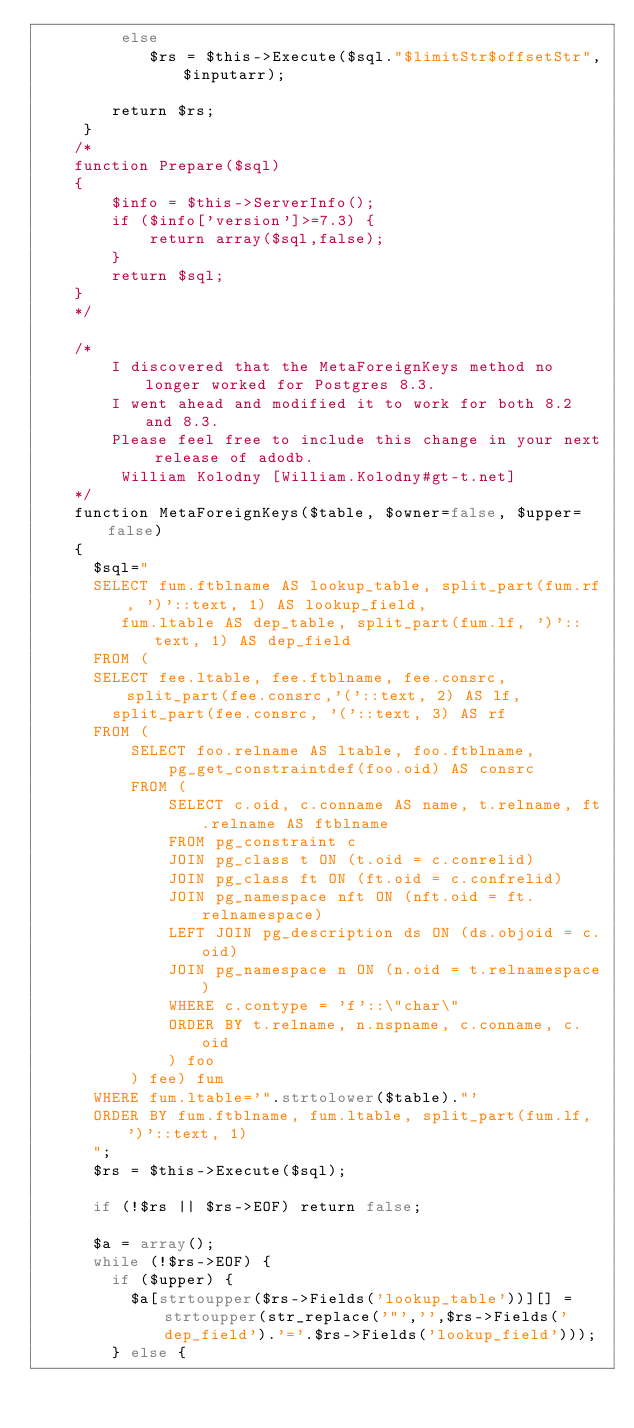<code> <loc_0><loc_0><loc_500><loc_500><_PHP_>		 else
		  	$rs = $this->Execute($sql."$limitStr$offsetStr",$inputarr);

		return $rs;
	 }
 	/*
 	function Prepare($sql)
	{
		$info = $this->ServerInfo();
		if ($info['version']>=7.3) {
			return array($sql,false);
		}
		return $sql;
	}
 	*/

	/*
		I discovered that the MetaForeignKeys method no longer worked for Postgres 8.3.
		I went ahead and modified it to work for both 8.2 and 8.3.
		Please feel free to include this change in your next release of adodb.
		 William Kolodny [William.Kolodny#gt-t.net]
	*/
	function MetaForeignKeys($table, $owner=false, $upper=false)
	{
	  $sql="
	  SELECT fum.ftblname AS lookup_table, split_part(fum.rf, ')'::text, 1) AS lookup_field,
	     fum.ltable AS dep_table, split_part(fum.lf, ')'::text, 1) AS dep_field
	  FROM (
	  SELECT fee.ltable, fee.ftblname, fee.consrc, split_part(fee.consrc,'('::text, 2) AS lf,
	    split_part(fee.consrc, '('::text, 3) AS rf
	  FROM (
	      SELECT foo.relname AS ltable, foo.ftblname,
	          pg_get_constraintdef(foo.oid) AS consrc
	      FROM (
	          SELECT c.oid, c.conname AS name, t.relname, ft.relname AS ftblname
	          FROM pg_constraint c
	          JOIN pg_class t ON (t.oid = c.conrelid)
	          JOIN pg_class ft ON (ft.oid = c.confrelid)
	          JOIN pg_namespace nft ON (nft.oid = ft.relnamespace)
	          LEFT JOIN pg_description ds ON (ds.objoid = c.oid)
	          JOIN pg_namespace n ON (n.oid = t.relnamespace)
	          WHERE c.contype = 'f'::\"char\"
	          ORDER BY t.relname, n.nspname, c.conname, c.oid
	          ) foo
	      ) fee) fum
	  WHERE fum.ltable='".strtolower($table)."'
	  ORDER BY fum.ftblname, fum.ltable, split_part(fum.lf, ')'::text, 1)
	  ";
	  $rs = $this->Execute($sql);

	  if (!$rs || $rs->EOF) return false;

	  $a = array();
	  while (!$rs->EOF) {
	    if ($upper) {
	      $a[strtoupper($rs->Fields('lookup_table'))][] = strtoupper(str_replace('"','',$rs->Fields('dep_field').'='.$rs->Fields('lookup_field')));
	    } else {</code> 